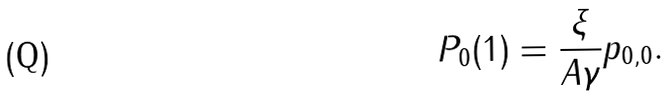Convert formula to latex. <formula><loc_0><loc_0><loc_500><loc_500>P _ { 0 } ( 1 ) = \frac { \xi } { A \gamma } p _ { 0 , 0 } .</formula> 